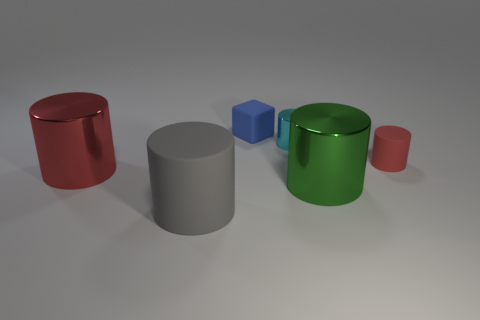Add 1 red things. How many objects exist? 7 Subtract all tiny red cylinders. How many cylinders are left? 4 Subtract all cylinders. How many objects are left? 1 Subtract 1 cylinders. How many cylinders are left? 4 Subtract all gray cylinders. How many cylinders are left? 4 Subtract 0 brown balls. How many objects are left? 6 Subtract all green cubes. Subtract all blue balls. How many cubes are left? 1 Subtract all blue spheres. How many green cylinders are left? 1 Subtract all large blocks. Subtract all big green cylinders. How many objects are left? 5 Add 6 large gray cylinders. How many large gray cylinders are left? 7 